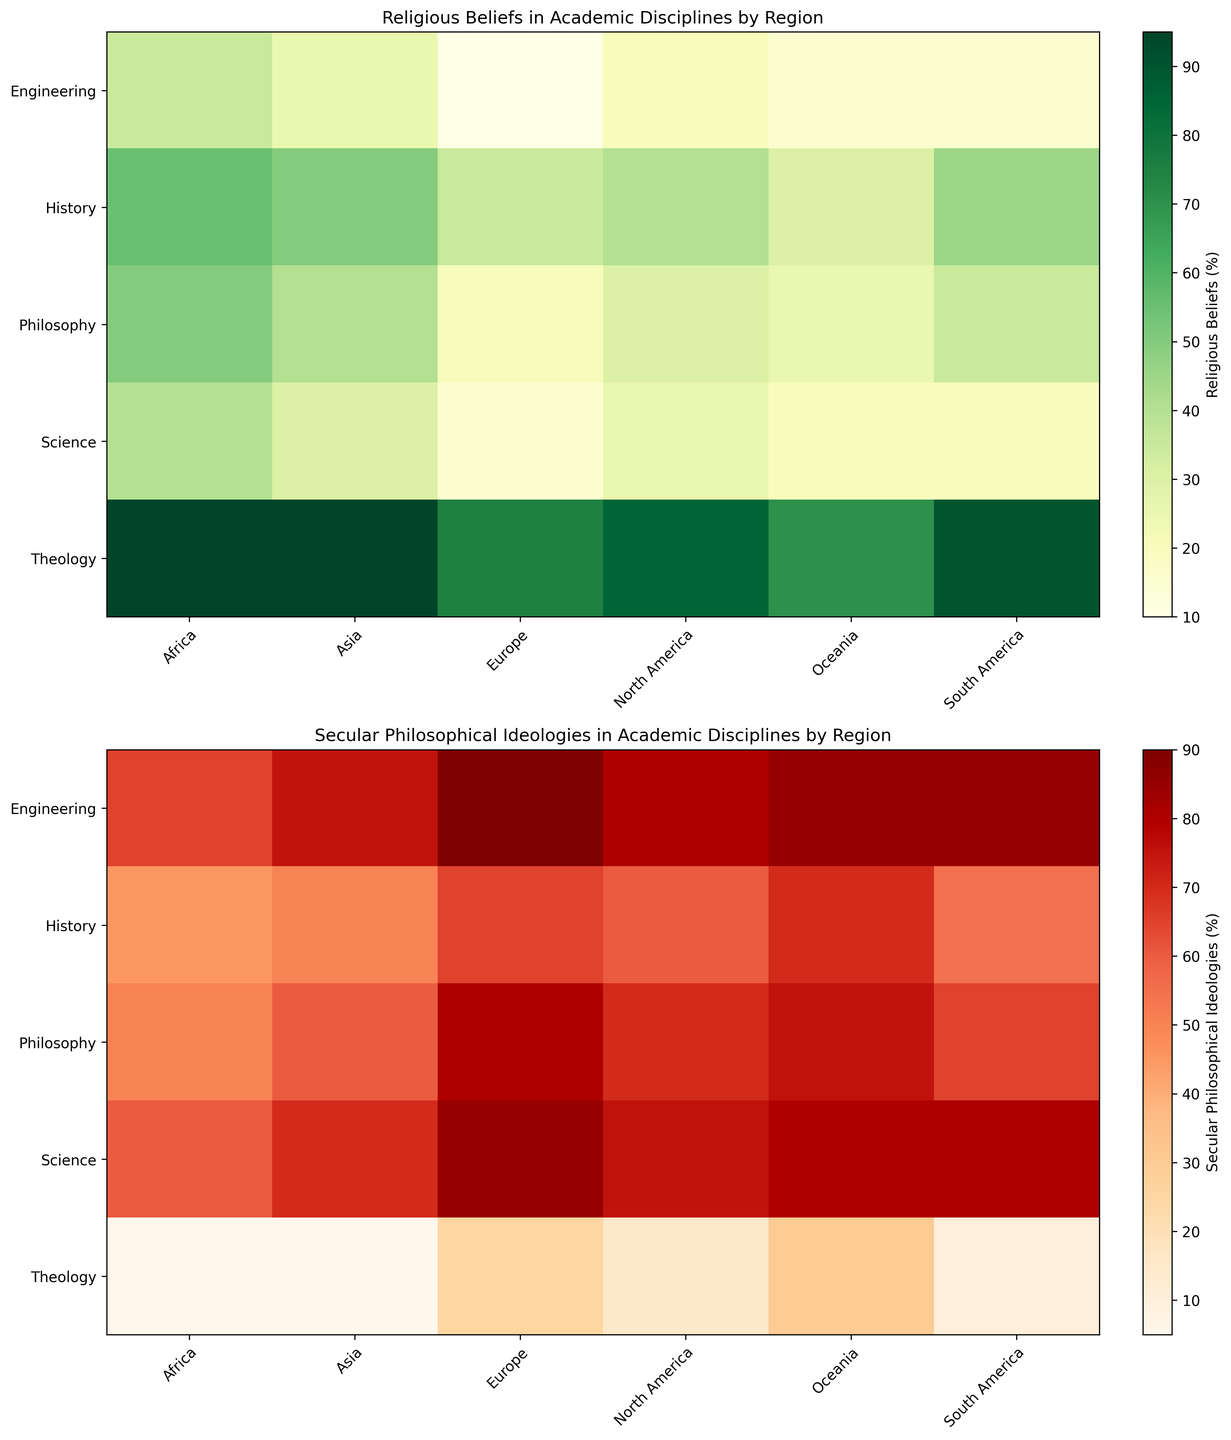What region has the highest percentage of Religious Beliefs in the Science discipline? By looking at the first heatmap (Religious Beliefs), the Science discipline has a 40% value in Africa. Checking other regions, 40% is the highest compared to 25% in North America, 15% in Europe, 30% in Asia, 20% in South America, and 20% in Oceania.
Answer: Africa Which academic discipline shows the greatest disparity between Religious Beliefs and Secular Philosophical Ideologies in Asia? In the first heatmap (Religious Beliefs), 'Theology' in Asia shows 95%, and the corresponding value in the second heatmap (Secular Philosophical Ideologies) is 5%, indicating a disparity of 90%. The other disciplines have a smaller disparity: Philosophy (40%), History (50%), Science (30%), and Engineering (25%).
Answer: Theology Compare the percentage of Religious Beliefs in Engineering between North America and Europe. Which region has a lower percentage? Examining the first heatmap (Religious Beliefs), North America shows 20% in Engineering, while Europe shows 10%. Therefore, Europe has a lower percentage of Religious Beliefs in Engineering compared to North America.
Answer: Europe Which region has the highest percentage of Secular Philosophical Ideologies in Engineering? By examining the second heatmap (Secular Philosophical Ideologies), Europe has the highest percentage in Engineering at 90% compared to other regions: North America (80%), Asia (75%), South America (85%), Africa (65%), and Oceania (85%).
Answer: Europe What is the difference in the percentage of Secular Philosophical Ideologies between History and Science in South America? In the second heatmap (Secular Philosophical Ideologies), South America shows 55% for History and 80% for Science. The difference is calculated as 80% - 55% = 25%.
Answer: 25% In which academic discipline does Oceania show the lowest percentage of Religious Beliefs? From the first heatmap (Religious Beliefs), the lowest percentage for Oceania is in Engineering with 15%.
Answer: Engineering Which three academic disciplines have the highest percentage of Religious Beliefs in North America? Referring to the first heatmap (Religious Beliefs) for North America: Theology (85%), History (40%), and Philosophy (30%).
Answer: Theology, History, Philosophy What is the average percentage of Religious Beliefs across all disciplines in Europe? The percentages in Europe from the first heatmap (Religious Beliefs) are: Theology (75%), Philosophy (20%), History (35%), Science (15%), Engineering (10%). The average is calculated as (75 + 20 + 35 + 15 + 10) / 5 = 31%.
Answer: 31% Which discipline exhibits the most balanced view in Africa, showing a close percentage between Religious Beliefs and Secular Philosophical Ideologies? From the first heatmap (Religious Beliefs) and the second (Secular Philosophical Ideologies) in Africa, 'History' shows 55% Religious Beliefs and 45% Secular Philosophical Ideologies, making it the most balanced compared to other disciplines.
Answer: History How does the percentage of Religious Beliefs in the Philosophy discipline differ between Africa and North America? From the first heatmap (Religious Beliefs), Philosophy in Africa is 50%, whereas in North America, it is 30%. The difference is 50% - 30% = 20%.
Answer: 20% 